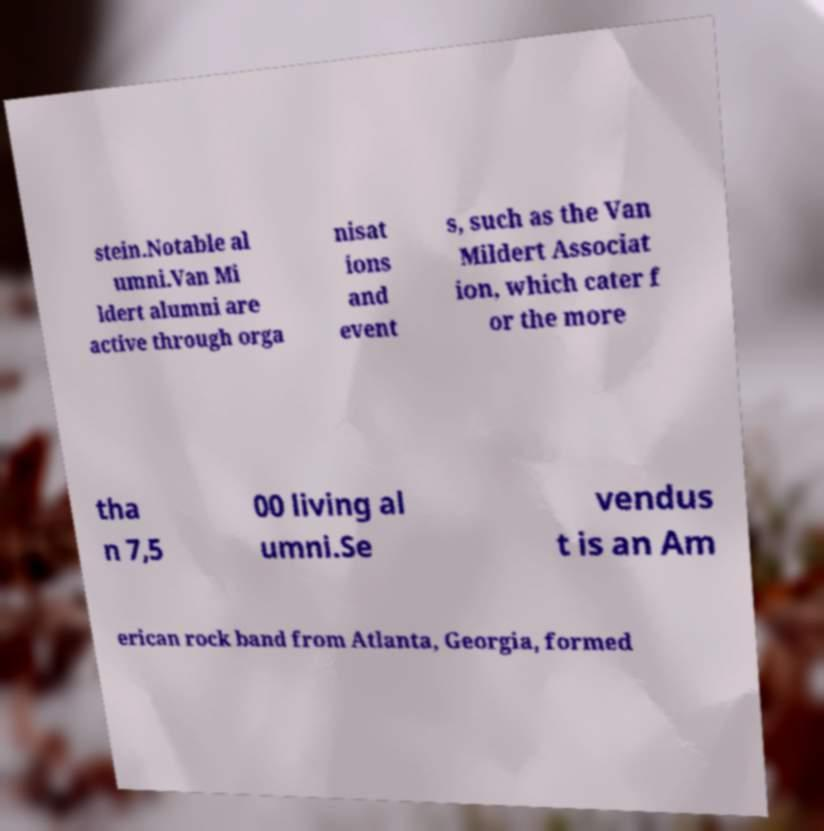For documentation purposes, I need the text within this image transcribed. Could you provide that? stein.Notable al umni.Van Mi ldert alumni are active through orga nisat ions and event s, such as the Van Mildert Associat ion, which cater f or the more tha n 7,5 00 living al umni.Se vendus t is an Am erican rock band from Atlanta, Georgia, formed 